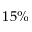Convert formula to latex. <formula><loc_0><loc_0><loc_500><loc_500>1 5 \%</formula> 